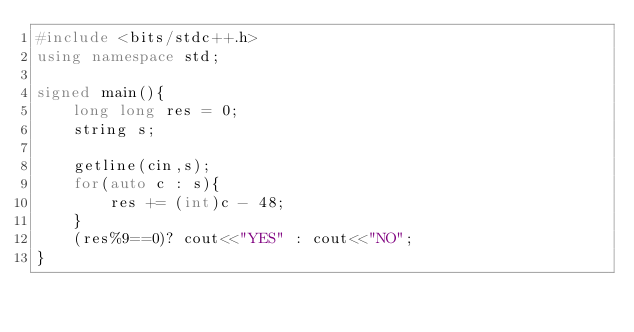Convert code to text. <code><loc_0><loc_0><loc_500><loc_500><_C++_>#include <bits/stdc++.h>
using namespace std;

signed main(){
    long long res = 0;
    string s;

    getline(cin,s);
    for(auto c : s){
        res += (int)c - 48;
    }
    (res%9==0)? cout<<"YES" : cout<<"NO";
}</code> 